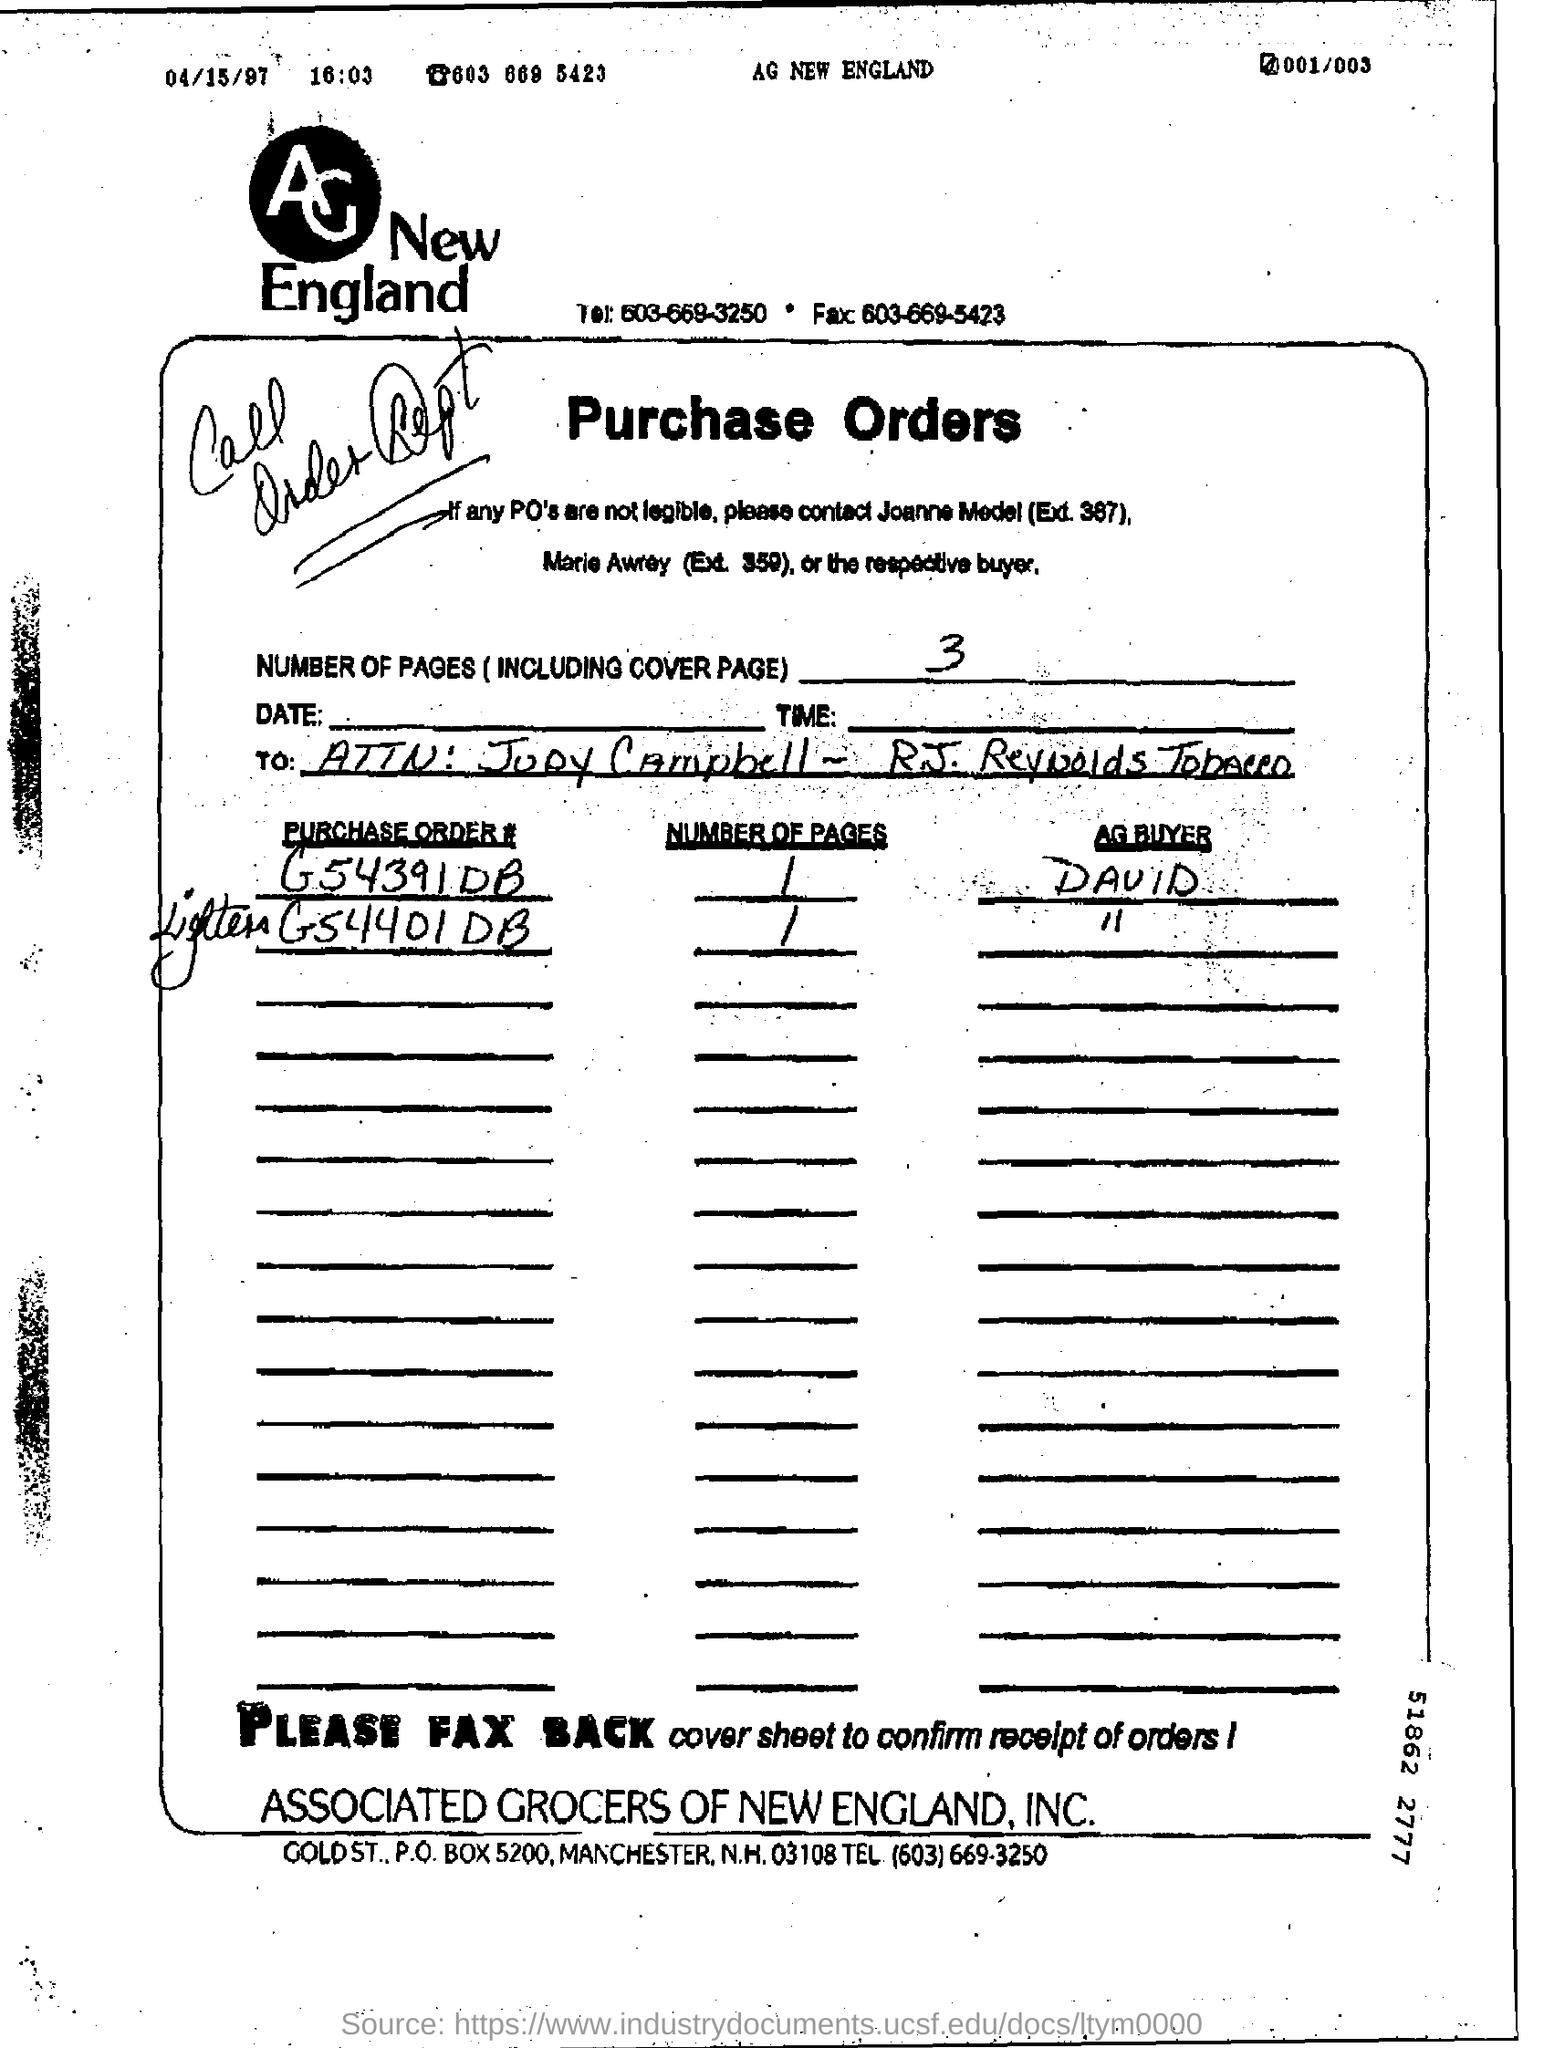How many pages are there including cover page?
Your response must be concise. 3. Who is the AG buyer for purchase order # G54391DB?
Offer a very short reply. David. 